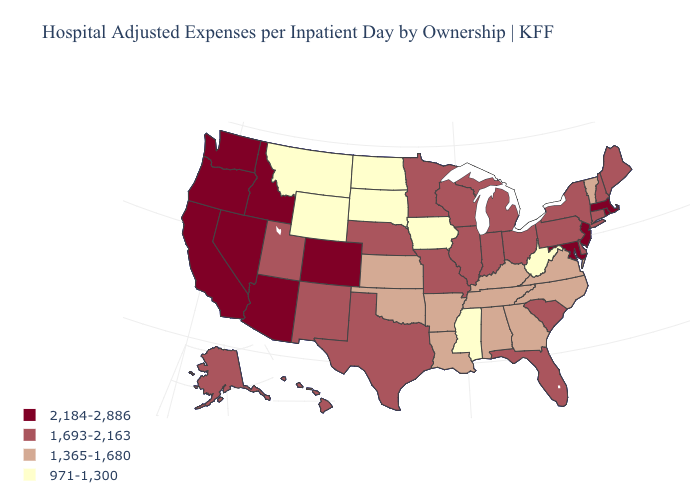What is the highest value in the USA?
Quick response, please. 2,184-2,886. What is the value of Illinois?
Quick response, please. 1,693-2,163. What is the lowest value in the Northeast?
Concise answer only. 1,365-1,680. What is the value of Arizona?
Write a very short answer. 2,184-2,886. Among the states that border Pennsylvania , which have the lowest value?
Concise answer only. West Virginia. Name the states that have a value in the range 1,365-1,680?
Concise answer only. Alabama, Arkansas, Georgia, Kansas, Kentucky, Louisiana, North Carolina, Oklahoma, Tennessee, Vermont, Virginia. Does Minnesota have a lower value than Missouri?
Be succinct. No. What is the lowest value in the USA?
Give a very brief answer. 971-1,300. Among the states that border Utah , which have the lowest value?
Be succinct. Wyoming. Name the states that have a value in the range 971-1,300?
Write a very short answer. Iowa, Mississippi, Montana, North Dakota, South Dakota, West Virginia, Wyoming. What is the lowest value in the USA?
Keep it brief. 971-1,300. Does Maryland have the lowest value in the USA?
Be succinct. No. What is the lowest value in the USA?
Write a very short answer. 971-1,300. Which states hav the highest value in the West?
Give a very brief answer. Arizona, California, Colorado, Idaho, Nevada, Oregon, Washington. What is the value of Kentucky?
Short answer required. 1,365-1,680. 